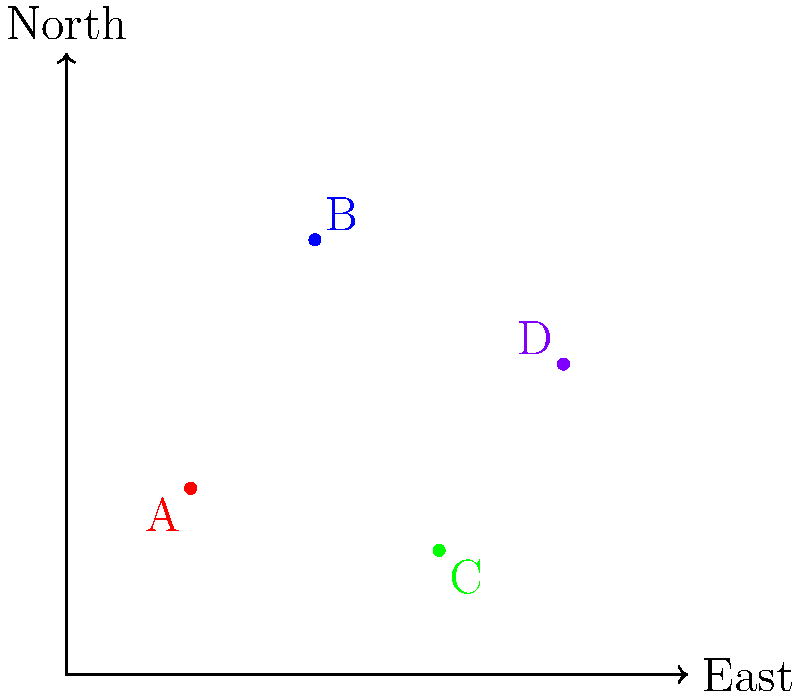On a city map, four restaurants are plotted using a coordinate system where each unit represents 1 km. Restaurant A is located at (2,3), B at (4,7), C at (6,2), and D at (8,5). Which two restaurants are closest to each other, potentially creating the strongest competition? To find the two closest restaurants, we need to calculate the distances between all pairs of restaurants using the distance formula:

$d = \sqrt{(x_2-x_1)^2 + (y_2-y_1)^2}$

1. Distance between A and B:
   $d_{AB} = \sqrt{(4-2)^2 + (7-3)^2} = \sqrt{4^2 + 4^2} = \sqrt{32} \approx 5.66$ km

2. Distance between A and C:
   $d_{AC} = \sqrt{(6-2)^2 + (2-3)^2} = \sqrt{4^2 + (-1)^2} = \sqrt{17} \approx 4.12$ km

3. Distance between A and D:
   $d_{AD} = \sqrt{(8-2)^2 + (5-3)^2} = \sqrt{6^2 + 2^2} = \sqrt{40} \approx 6.32$ km

4. Distance between B and C:
   $d_{BC} = \sqrt{(6-4)^2 + (2-7)^2} = \sqrt{2^2 + (-5)^2} = \sqrt{29} \approx 5.39$ km

5. Distance between B and D:
   $d_{BD} = \sqrt{(8-4)^2 + (5-7)^2} = \sqrt{4^2 + (-2)^2} = \sqrt{20} \approx 4.47$ km

6. Distance between C and D:
   $d_{CD} = \sqrt{(8-6)^2 + (5-2)^2} = \sqrt{2^2 + 3^2} = \sqrt{13} \approx 3.61$ km

The shortest distance is between restaurants C and D, approximately 3.61 km apart.
Answer: C and D 